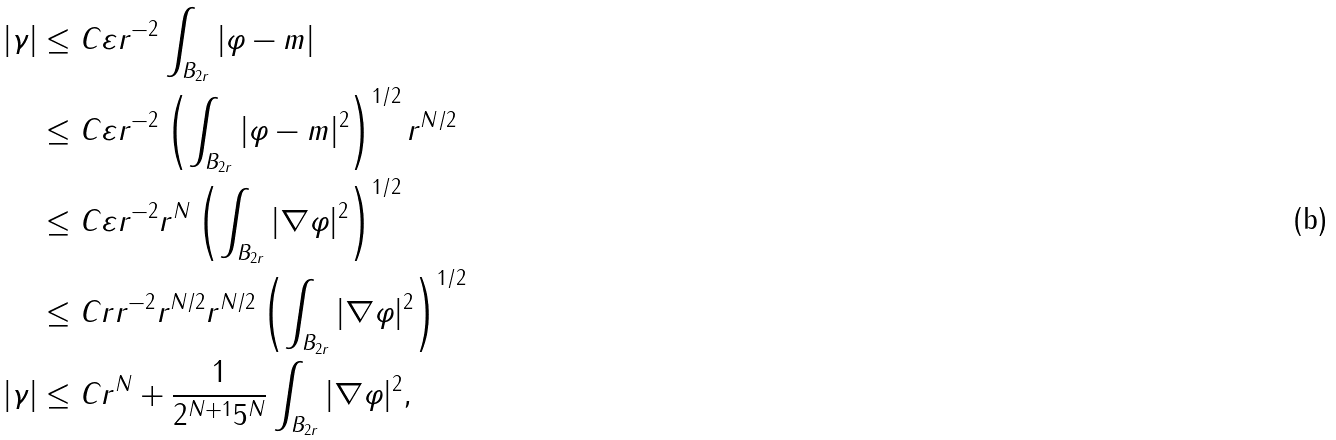<formula> <loc_0><loc_0><loc_500><loc_500>| \gamma | & \leq C \varepsilon r ^ { - 2 } \int _ { B _ { 2 r } } | \varphi - m | \\ & \leq C \varepsilon r ^ { - 2 } \left ( \int _ { B _ { 2 r } } | \varphi - m | ^ { 2 } \right ) ^ { 1 / 2 } r ^ { N / 2 } \\ & \leq C \varepsilon r ^ { - 2 } r ^ { N } \left ( \int _ { B _ { 2 r } } | \nabla \varphi | ^ { 2 } \right ) ^ { 1 / 2 } \\ & \leq C r r ^ { - 2 } r ^ { N / 2 } r ^ { N / 2 } \left ( \int _ { B _ { 2 r } } | \nabla \varphi | ^ { 2 } \right ) ^ { 1 / 2 } \\ | \gamma | & \leq C r ^ { N } + \frac { 1 } { 2 ^ { N + 1 } 5 ^ { N } } \int _ { B _ { 2 r } } | \nabla \varphi | ^ { 2 } ,</formula> 